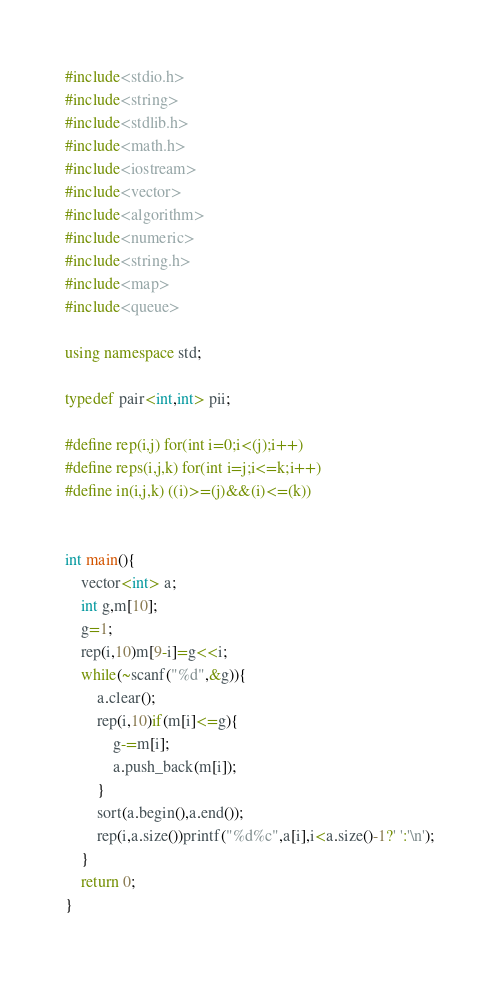<code> <loc_0><loc_0><loc_500><loc_500><_C++_>#include<stdio.h>
#include<string>
#include<stdlib.h>
#include<math.h>
#include<iostream>
#include<vector>
#include<algorithm>
#include<numeric>
#include<string.h>
#include<map>
#include<queue>

using namespace std;

typedef pair<int,int> pii;

#define rep(i,j) for(int i=0;i<(j);i++)
#define reps(i,j,k) for(int i=j;i<=k;i++)
#define in(i,j,k) ((i)>=(j)&&(i)<=(k))


int main(){
	vector<int> a;
	int g,m[10];
	g=1;
	rep(i,10)m[9-i]=g<<i;
	while(~scanf("%d",&g)){
		a.clear();
		rep(i,10)if(m[i]<=g){
			g-=m[i];
			a.push_back(m[i]);
		}
		sort(a.begin(),a.end());
		rep(i,a.size())printf("%d%c",a[i],i<a.size()-1?' ':'\n');
	}
	return 0;
}</code> 